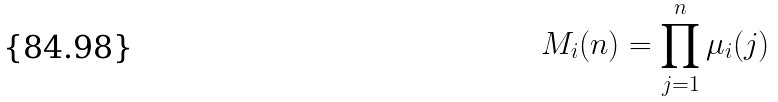<formula> <loc_0><loc_0><loc_500><loc_500>M _ { i } ( n ) = \prod _ { j = 1 } ^ { n } \mu _ { i } ( j )</formula> 